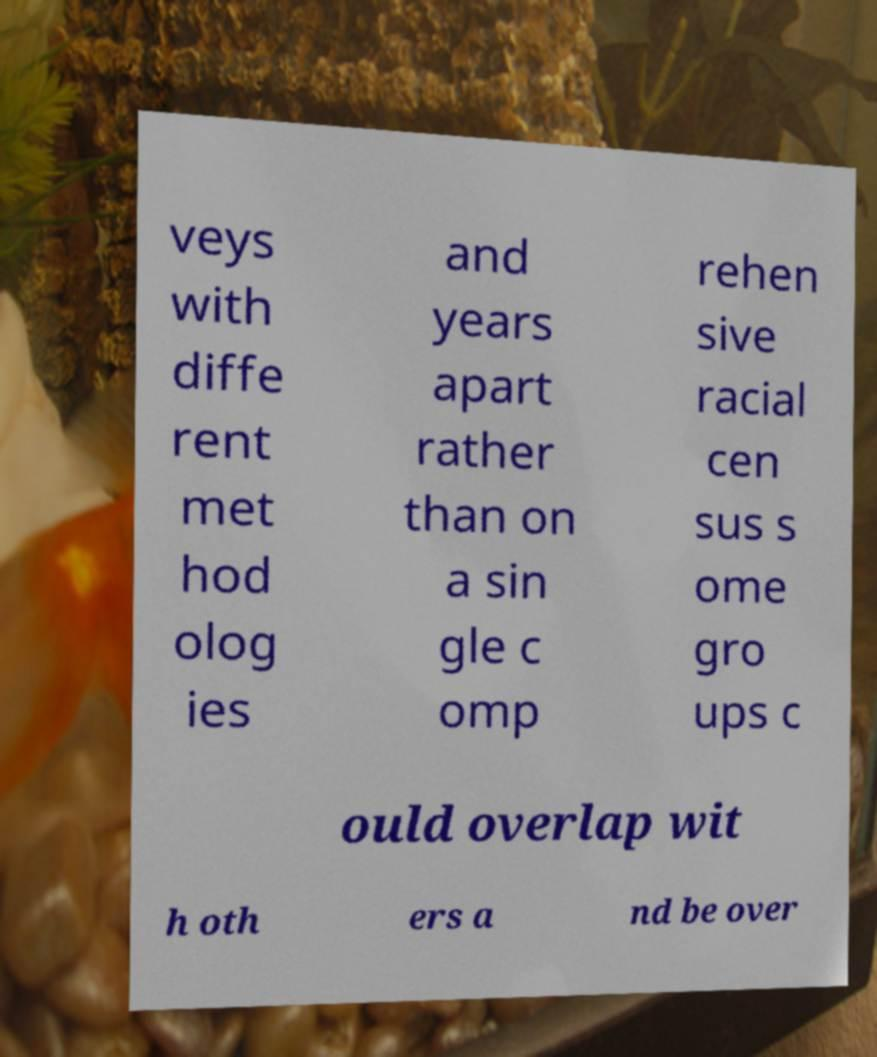Could you assist in decoding the text presented in this image and type it out clearly? veys with diffe rent met hod olog ies and years apart rather than on a sin gle c omp rehen sive racial cen sus s ome gro ups c ould overlap wit h oth ers a nd be over 